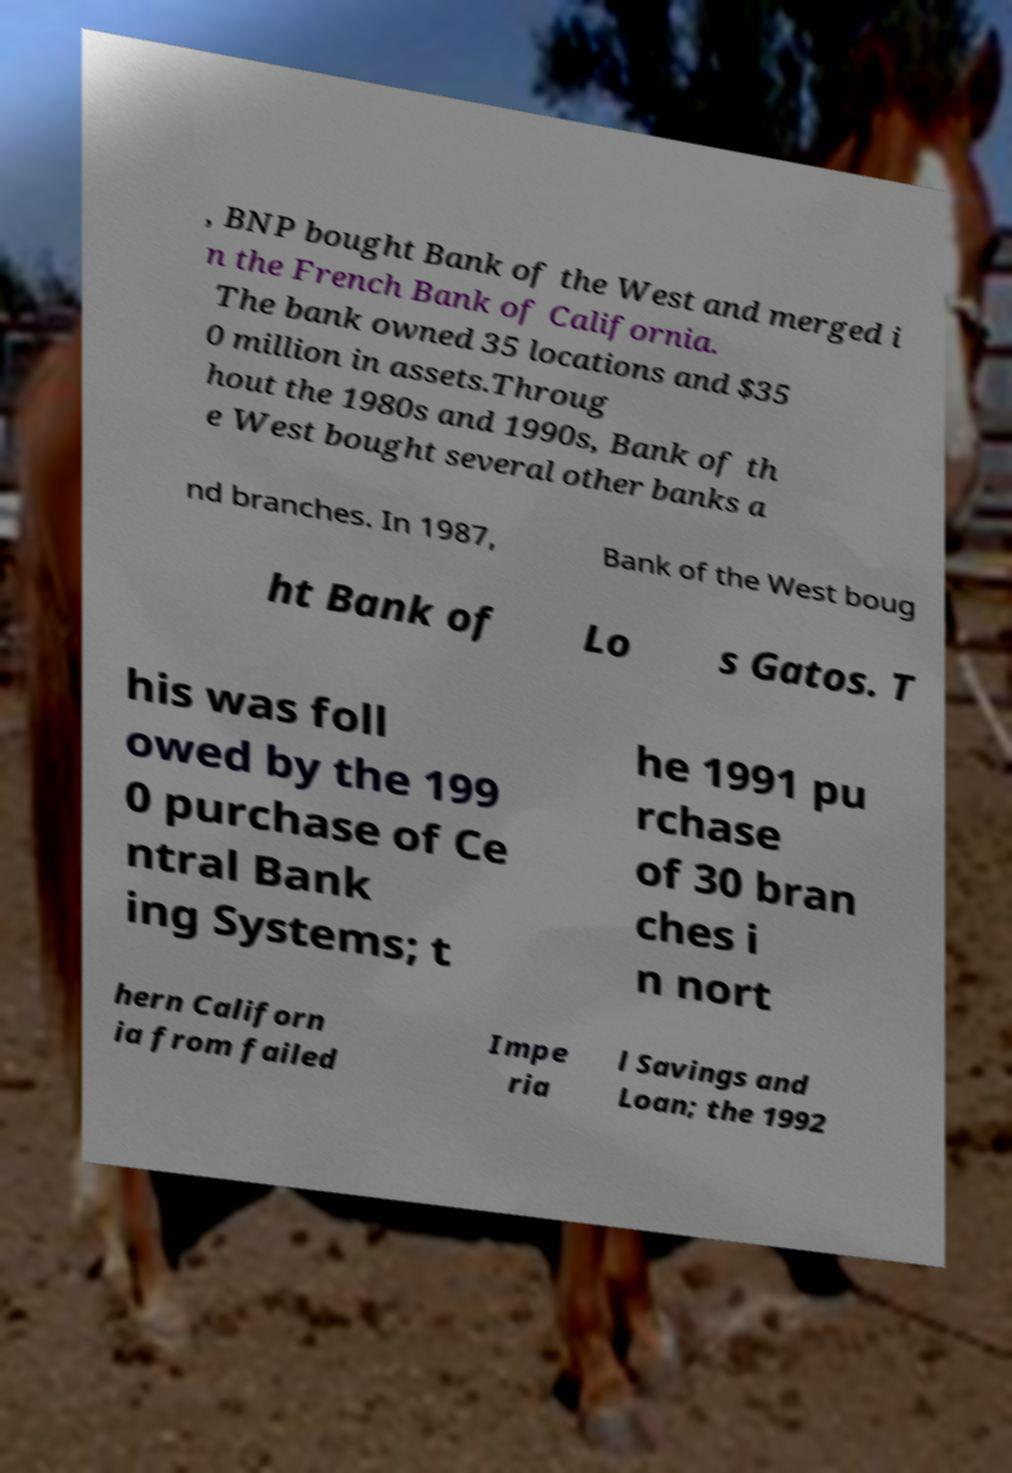Can you read and provide the text displayed in the image?This photo seems to have some interesting text. Can you extract and type it out for me? , BNP bought Bank of the West and merged i n the French Bank of California. The bank owned 35 locations and $35 0 million in assets.Throug hout the 1980s and 1990s, Bank of th e West bought several other banks a nd branches. In 1987, Bank of the West boug ht Bank of Lo s Gatos. T his was foll owed by the 199 0 purchase of Ce ntral Bank ing Systems; t he 1991 pu rchase of 30 bran ches i n nort hern Californ ia from failed Impe ria l Savings and Loan; the 1992 